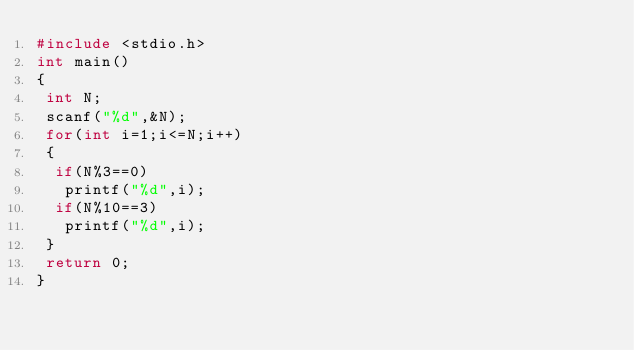Convert code to text. <code><loc_0><loc_0><loc_500><loc_500><_C_>#include <stdio.h>
int main()
{
 int N;
 scanf("%d",&N);
 for(int i=1;i<=N;i++)
 {
  if(N%3==0)
   printf("%d",i);
  if(N%10==3)
   printf("%d",i);
 }
 return 0;
}</code> 